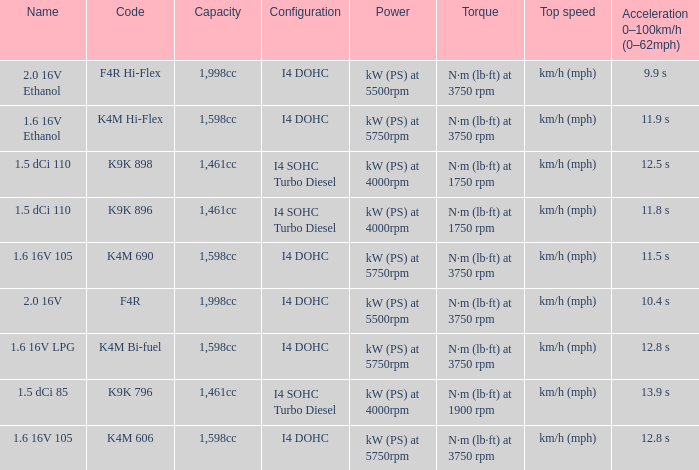Parse the full table. {'header': ['Name', 'Code', 'Capacity', 'Configuration', 'Power', 'Torque', 'Top speed', 'Acceleration 0–100km/h (0–62mph)'], 'rows': [['2.0 16V Ethanol', 'F4R Hi-Flex', '1,998cc', 'I4 DOHC', 'kW (PS) at 5500rpm', 'N·m (lb·ft) at 3750 rpm', 'km/h (mph)', '9.9 s'], ['1.6 16V Ethanol', 'K4M Hi-Flex', '1,598cc', 'I4 DOHC', 'kW (PS) at 5750rpm', 'N·m (lb·ft) at 3750 rpm', 'km/h (mph)', '11.9 s'], ['1.5 dCi 110', 'K9K 898', '1,461cc', 'I4 SOHC Turbo Diesel', 'kW (PS) at 4000rpm', 'N·m (lb·ft) at 1750 rpm', 'km/h (mph)', '12.5 s'], ['1.5 dCi 110', 'K9K 896', '1,461cc', 'I4 SOHC Turbo Diesel', 'kW (PS) at 4000rpm', 'N·m (lb·ft) at 1750 rpm', 'km/h (mph)', '11.8 s'], ['1.6 16V 105', 'K4M 690', '1,598cc', 'I4 DOHC', 'kW (PS) at 5750rpm', 'N·m (lb·ft) at 3750 rpm', 'km/h (mph)', '11.5 s'], ['2.0 16V', 'F4R', '1,998cc', 'I4 DOHC', 'kW (PS) at 5500rpm', 'N·m (lb·ft) at 3750 rpm', 'km/h (mph)', '10.4 s'], ['1.6 16V LPG', 'K4M Bi-fuel', '1,598cc', 'I4 DOHC', 'kW (PS) at 5750rpm', 'N·m (lb·ft) at 3750 rpm', 'km/h (mph)', '12.8 s'], ['1.5 dCi 85', 'K9K 796', '1,461cc', 'I4 SOHC Turbo Diesel', 'kW (PS) at 4000rpm', 'N·m (lb·ft) at 1900 rpm', 'km/h (mph)', '13.9 s'], ['1.6 16V 105', 'K4M 606', '1,598cc', 'I4 DOHC', 'kW (PS) at 5750rpm', 'N·m (lb·ft) at 3750 rpm', 'km/h (mph)', '12.8 s']]} What is the code of 1.5 dci 110, which has a capacity of 1,461cc? K9K 896, K9K 898. 